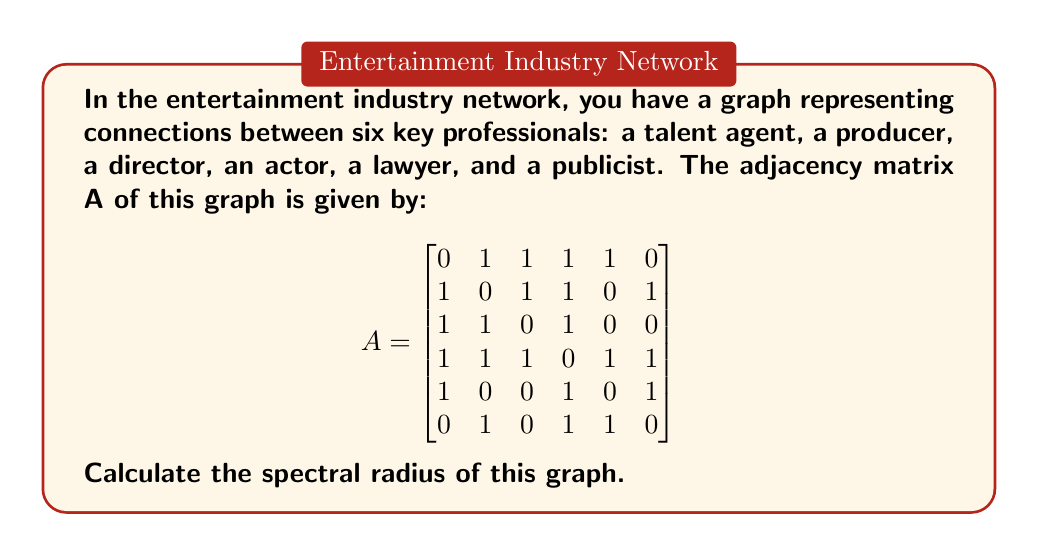Provide a solution to this math problem. To calculate the spectral radius of the graph, we need to follow these steps:

1) The spectral radius is the largest absolute eigenvalue of the adjacency matrix A.

2) To find the eigenvalues, we need to solve the characteristic equation:
   $$det(A - \lambda I) = 0$$
   where I is the 6x6 identity matrix and λ represents the eigenvalues.

3) Expanding this determinant leads to a 6th degree polynomial equation, which is complex to solve by hand. In practice, we would use numerical methods or computer software to find the eigenvalues.

4) Using a computer algebra system, we find that the eigenvalues of A are approximately:
   $$\lambda_1 \approx 3.2361$$
   $$\lambda_2 \approx -1.7321$$
   $$\lambda_3 \approx 0.8990$$
   $$\lambda_4 \approx -0.5590$$
   $$\lambda_5 \approx 0.1560$$
   $$\lambda_6 \approx 0$$

5) The spectral radius is the largest absolute value among these eigenvalues.

6) Therefore, the spectral radius is approximately 3.2361.

This value represents the maximum influence or connectivity in the network. As an entertainment lawyer, you might interpret this as indicating a highly interconnected industry where information and influence can spread quickly through the network.
Answer: $$3.2361$$ 